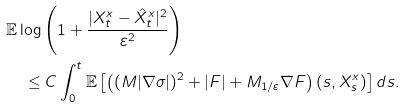<formula> <loc_0><loc_0><loc_500><loc_500>& \mathbb { E } \log \left ( 1 + \frac { | X ^ { x } _ { t } - \hat { X } ^ { x } _ { t } | ^ { 2 } } { \varepsilon ^ { 2 } } \right ) \\ & \quad \leq C \int _ { 0 } ^ { t } \mathbb { E } \left [ \left ( ( M | \nabla \sigma | ) ^ { 2 } + | F | + M _ { 1 / \varepsilon } \nabla F \right ) ( s , X ^ { x } _ { s } ) \right ] d s .</formula> 